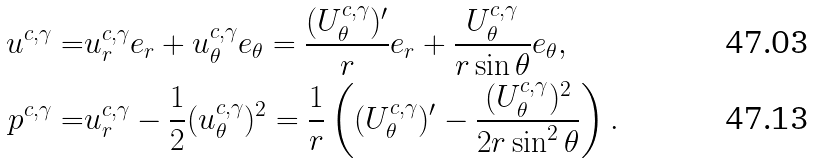Convert formula to latex. <formula><loc_0><loc_0><loc_500><loc_500>u ^ { c , \gamma } = & u _ { r } ^ { c , \gamma } e _ { r } + u _ { \theta } ^ { c , \gamma } e _ { \theta } = \frac { ( U _ { \theta } ^ { c , \gamma } ) ^ { \prime } } { r } e _ { r } + \frac { U _ { \theta } ^ { c , \gamma } } { r \sin \theta } e _ { \theta } , \\ p ^ { c , \gamma } = & u _ { r } ^ { c , \gamma } - \frac { 1 } { 2 } ( u _ { \theta } ^ { c , \gamma } ) ^ { 2 } = \frac { 1 } { r } \left ( ( U _ { \theta } ^ { c , \gamma } ) ^ { \prime } - \frac { ( U _ { \theta } ^ { c , \gamma } ) ^ { 2 } } { 2 r \sin ^ { 2 } \theta } \right ) .</formula> 